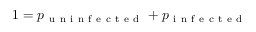Convert formula to latex. <formula><loc_0><loc_0><loc_500><loc_500>1 = p _ { u n i n f e c t e d } + p _ { i n f e c t e d }</formula> 